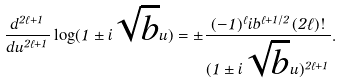Convert formula to latex. <formula><loc_0><loc_0><loc_500><loc_500>\frac { d ^ { 2 \ell + 1 } } { d u ^ { 2 \ell + 1 } } \log ( 1 \pm i \sqrt { b } u ) = \pm \frac { ( - 1 ) ^ { \ell } i b ^ { \ell + 1 / 2 } ( 2 \ell ) ! } { ( 1 \pm i \sqrt { b } u ) ^ { 2 \ell + 1 } } .</formula> 